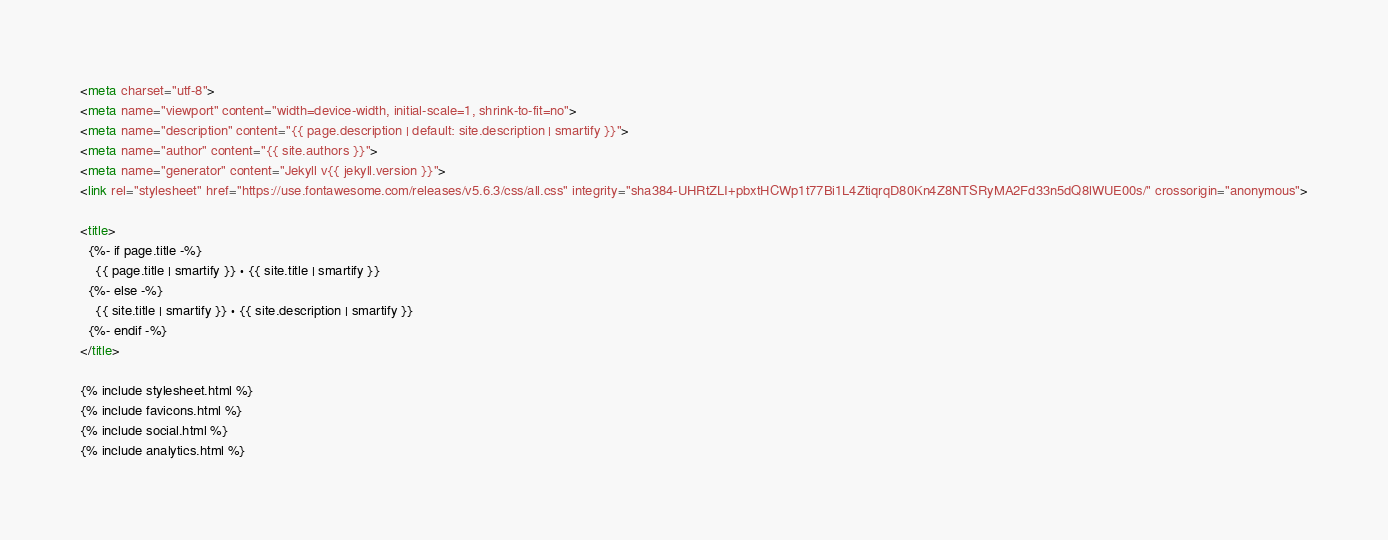<code> <loc_0><loc_0><loc_500><loc_500><_HTML_><meta charset="utf-8">
<meta name="viewport" content="width=device-width, initial-scale=1, shrink-to-fit=no">
<meta name="description" content="{{ page.description | default: site.description | smartify }}">
<meta name="author" content="{{ site.authors }}">
<meta name="generator" content="Jekyll v{{ jekyll.version }}">
<link rel="stylesheet" href="https://use.fontawesome.com/releases/v5.6.3/css/all.css" integrity="sha384-UHRtZLI+pbxtHCWp1t77Bi1L4ZtiqrqD80Kn4Z8NTSRyMA2Fd33n5dQ8lWUE00s/" crossorigin="anonymous">

<title>
  {%- if page.title -%}
    {{ page.title | smartify }} · {{ site.title | smartify }}
  {%- else -%}
    {{ site.title | smartify }} · {{ site.description | smartify }}
  {%- endif -%}
</title>

{% include stylesheet.html %}
{% include favicons.html %}
{% include social.html %}
{% include analytics.html %}
</code> 